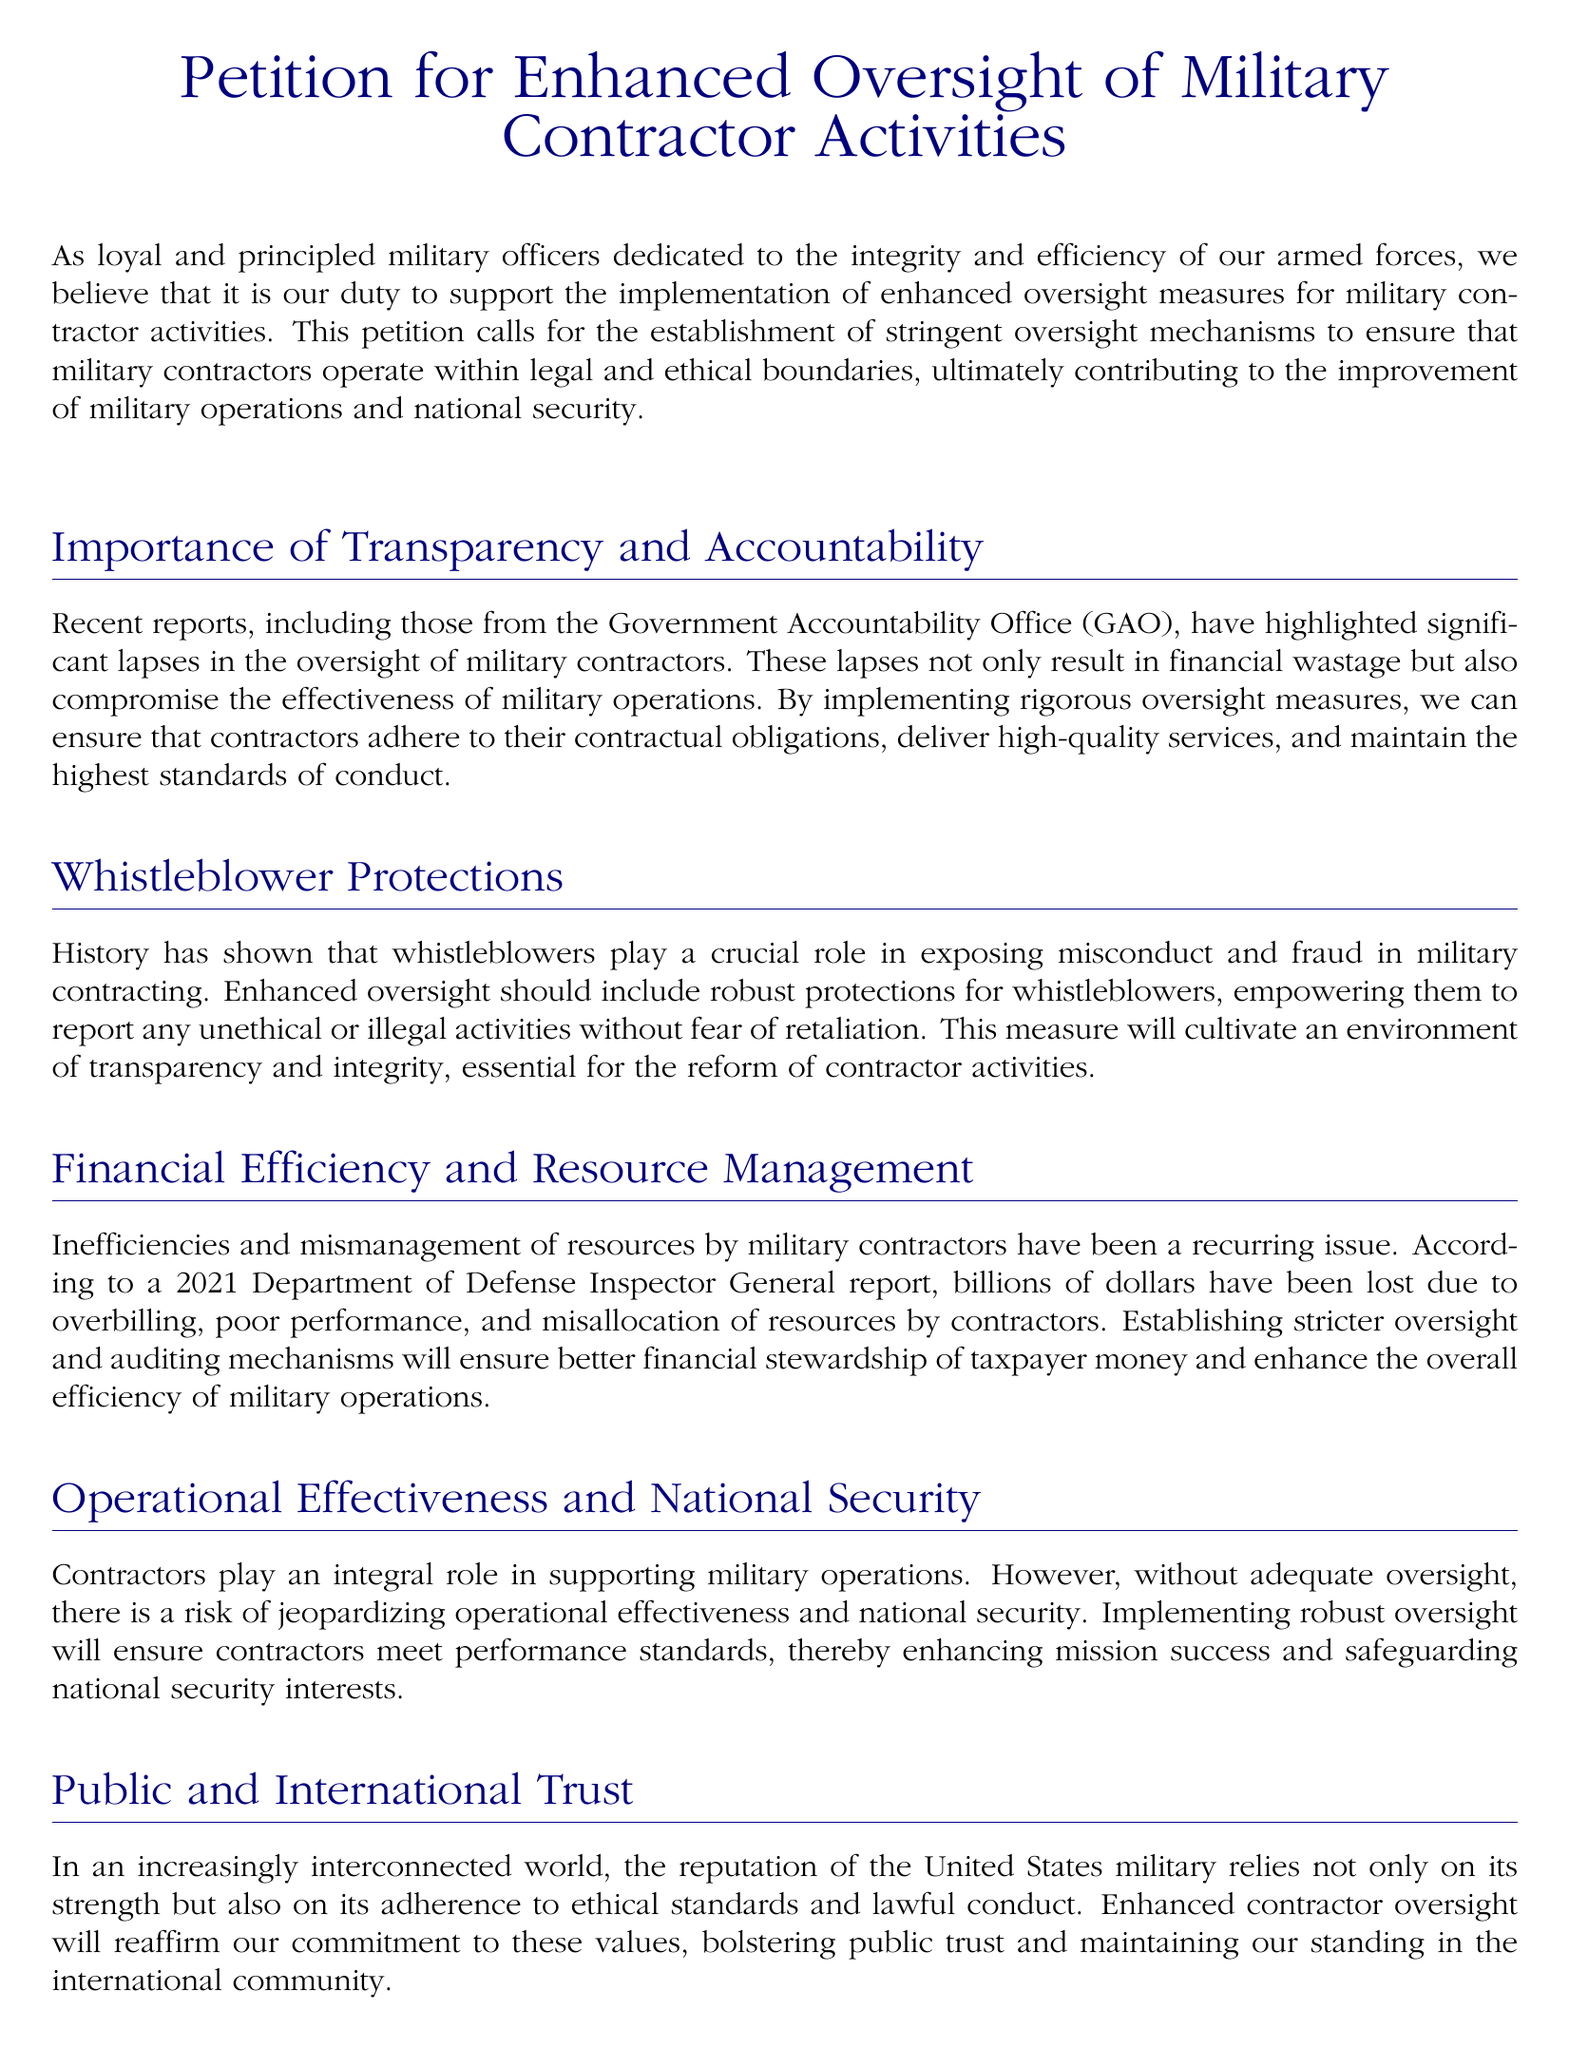What is the title of the petition? The title of the petition is explicitly stated at the beginning of the document.
Answer: Petition for Enhanced Oversight of Military Contractor Activities Who authored this petition? The petition states that it is authored by loyal and principled military officers.
Answer: Military officers What organization highlighted significant lapses in oversight? The Government Accountability Office (GAO) is mentioned as highlighting lapses in oversight in the document.
Answer: Government Accountability Office (GAO) What is a major concern regarding military contractors mentioned in the petition? The document refers to inefficiencies and mismanagement of resources as major concerns with military contractors.
Answer: Inefficiencies and mismanagement What type of protections should be included in enhanced oversight? The petition advocates for robust protections for whistleblowers.
Answer: Whistleblower protections According to a 2021 report, how much money has been lost due to contractor issues? The document states that billions of dollars have been lost due to issues like overbilling and poor performance.
Answer: Billions of dollars What is the ultimate goal of implementing enhanced oversight according to the document? The goal of enhanced oversight is to safeguard the integrity of the military and the judicious use of taxpayer funds.
Answer: Safeguarding integrity What will enhanced oversight help to improve in terms of military operations? Enhanced oversight is aimed at improving operational effectiveness and national security.
Answer: Operational effectiveness and national security Who is urged to take action regarding enhanced oversight? The petition urges the Department of Defense and relevant legislative bodies to take action.
Answer: Department of Defense and relevant legislative bodies 